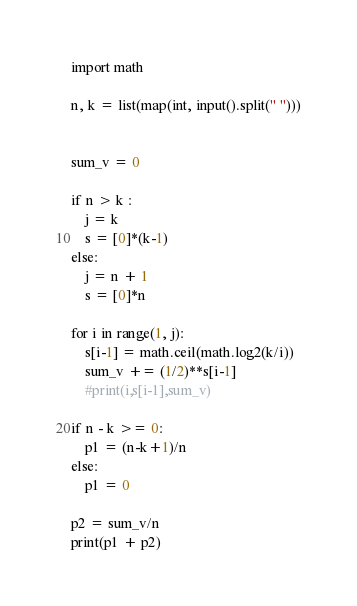<code> <loc_0><loc_0><loc_500><loc_500><_Python_>import math

n, k = list(map(int, input().split(" ")))


sum_v = 0

if n > k :
    j = k
    s = [0]*(k-1)
else:
    j = n + 1
    s = [0]*n
    
for i in range(1, j):
    s[i-1] = math.ceil(math.log2(k/i))
    sum_v += (1/2)**s[i-1]
    #print(i,s[i-1],sum_v)
    
if n - k >= 0: 
    p1 = (n-k+1)/n
else:
    p1 = 0
    
p2 = sum_v/n
print(p1 + p2)</code> 